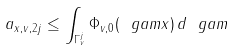Convert formula to latex. <formula><loc_0><loc_0><loc_500><loc_500>a _ { x , v , 2 j } \leq \int _ { \Gamma _ { v } ^ { j } } \Phi _ { v , 0 } ( \ g a m x ) \, d \ g a m</formula> 